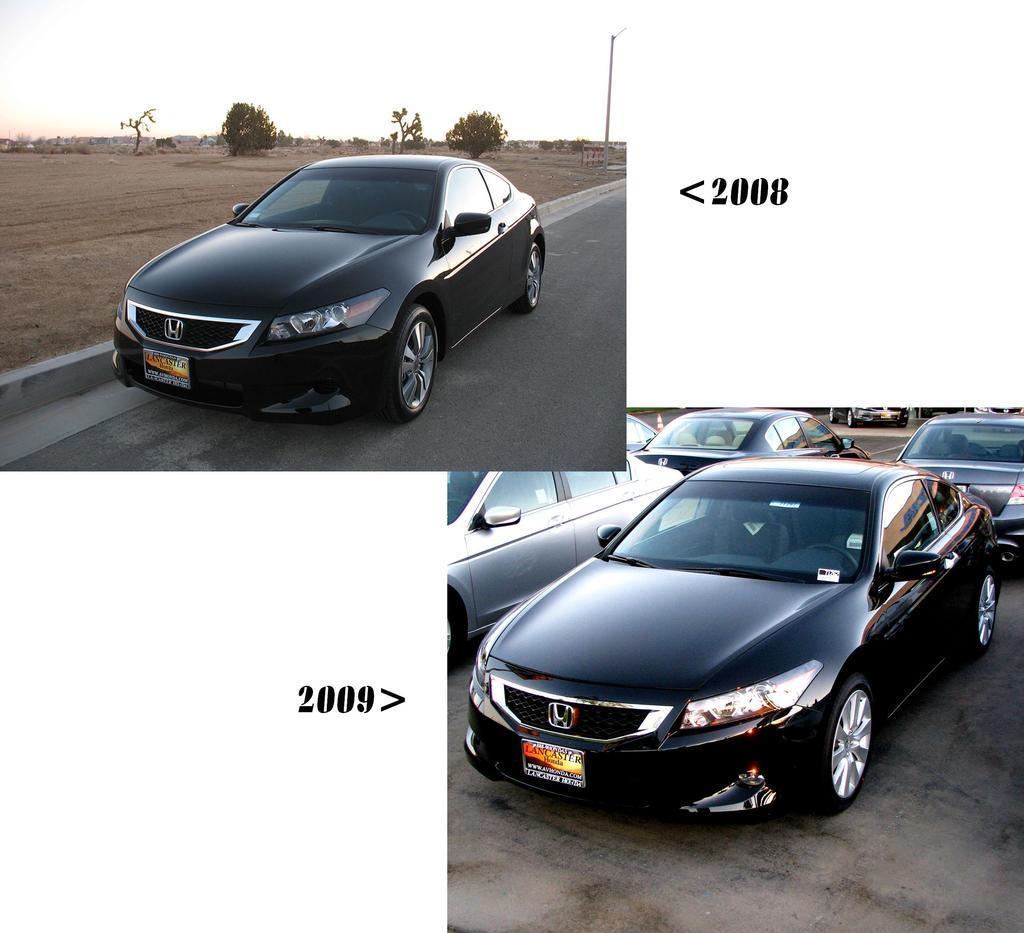Describe this image in one or two sentences. In this image we can see few cars, there are some trees, there is a rod, and we can see ground. 